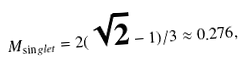<formula> <loc_0><loc_0><loc_500><loc_500>M _ { \sin g l e t } = 2 ( \sqrt { 2 } - 1 ) / 3 \approx 0 . 2 7 6 ,</formula> 